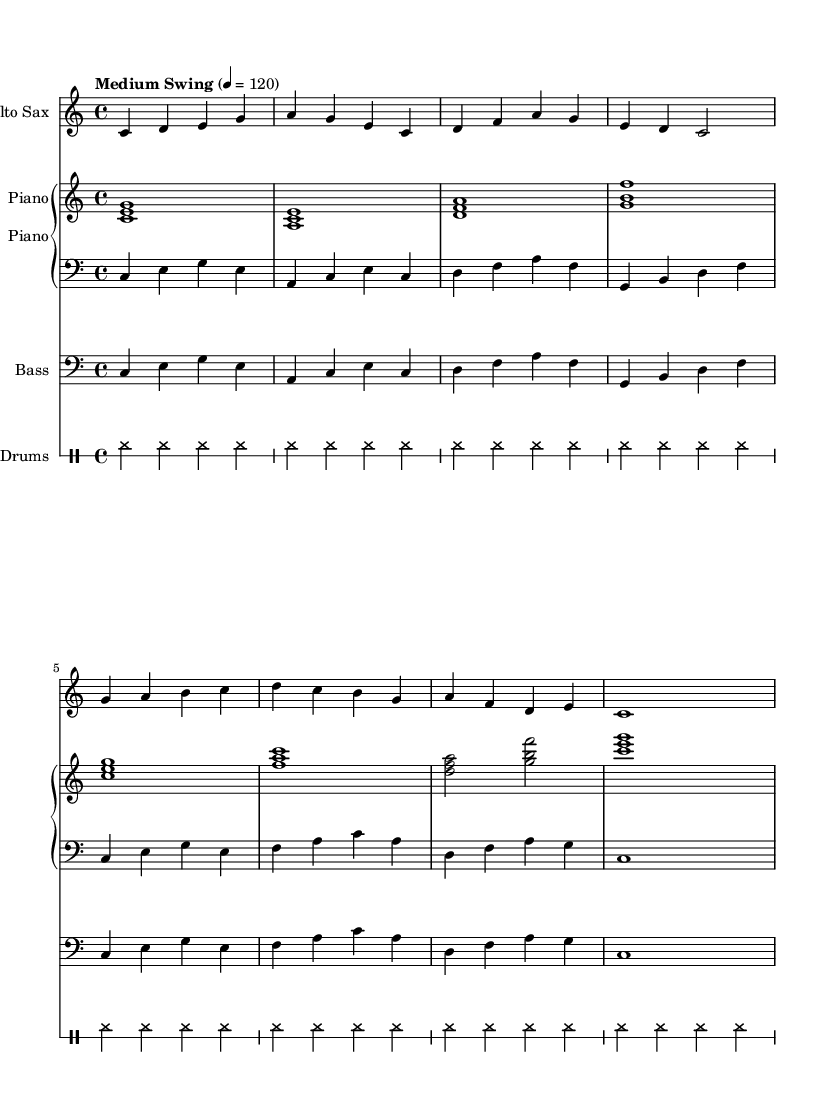What is the key signature of this music? The key signature is C major, which has no sharps or flats.
Answer: C major What is the time signature of the piece? The time signature indicates a regular rhythmic structure that is commonly used, and it shows that there are four beats in each measure. The displayed time signature is 4/4.
Answer: 4/4 What tempo marking is given for the piece? The sheet music indicates a tempo marking that guides the performer on the speed of the piece; here, it's set to a medium swing at 120 beats per minute.
Answer: Medium Swing 4 = 120 How many measures are there in the alto saxophone part? By counting the measures in the written part for the alto sax, we see that there are a total of eight measures.
Answer: 8 What type of musical ensemble is indicated by the score? The instrumentation shown consists of four different parts: an alto saxophone, piano (with right-hand and left-hand parts), bass, and drums, indicating a small jazz ensemble configuration.
Answer: Jazz ensemble Which instrument plays a bass clef? In this score, the bass part is explicitly notated in a bass clef, which is a visual cue to the reader that this part is meant for lower-pitched instruments.
Answer: Bass 